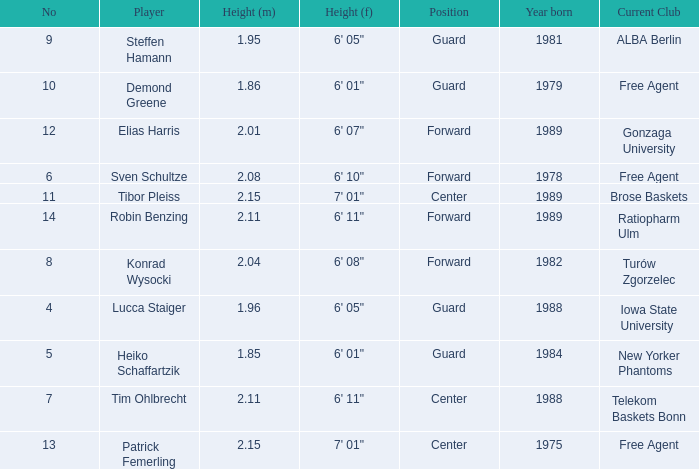Name the height for steffen hamann 6' 05". 